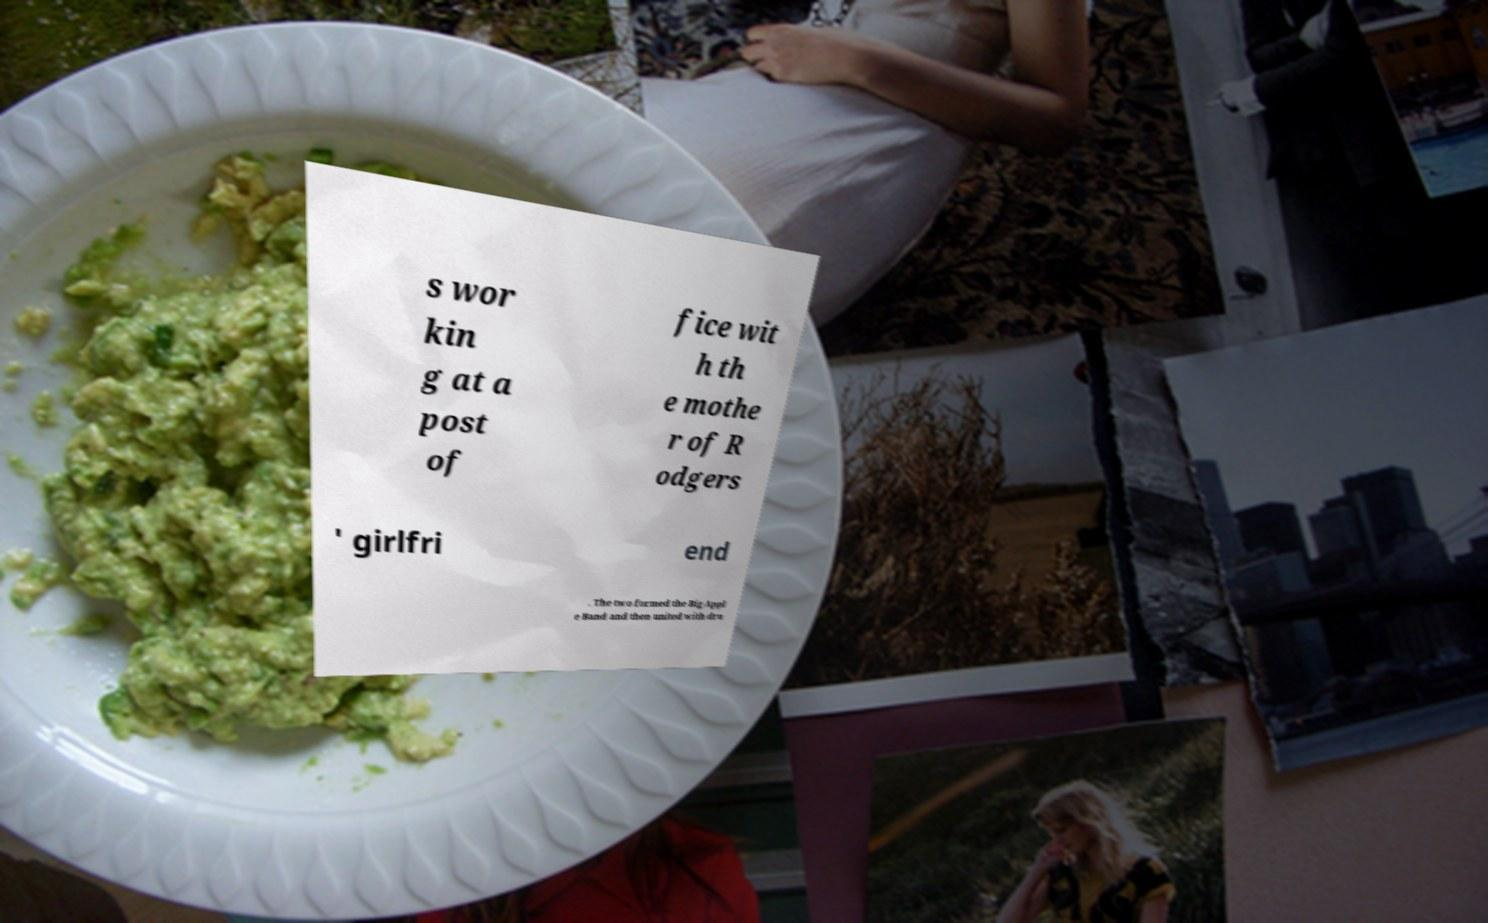Can you accurately transcribe the text from the provided image for me? s wor kin g at a post of fice wit h th e mothe r of R odgers ' girlfri end . The two formed the Big Appl e Band and then united with dru 